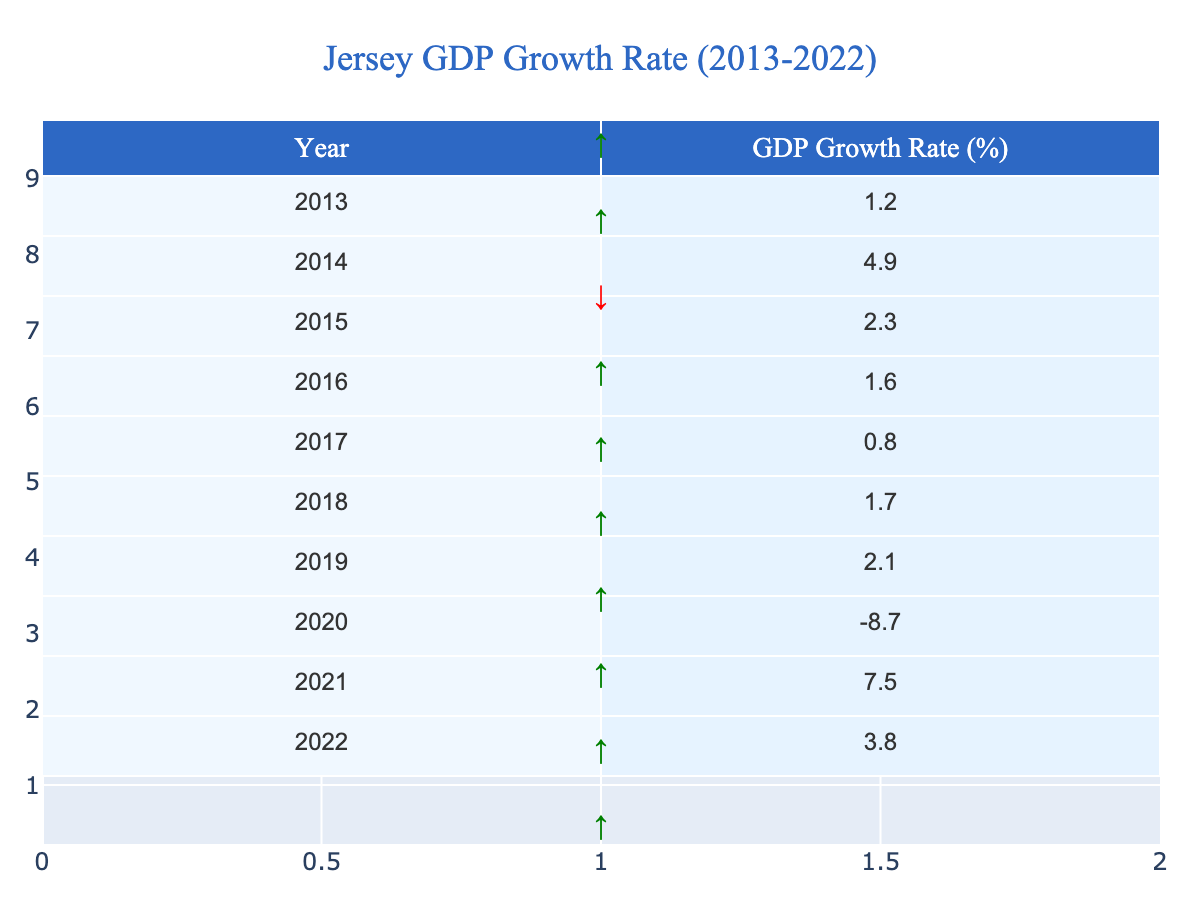What was the GDP growth rate in 2020? The table shows that the GDP growth rate for the year 2020 is recorded as -8.7%.
Answer: -8.7% Which year saw the highest GDP growth rate? According to the table, the highest GDP growth rate of 4.9% occurred in 2014.
Answer: 2014 What is the average GDP growth rate from 2013 to 2022? To find the average, we sum the GDP growth rates from each year: (1.2 + 4.9 + 2.3 + 1.6 + 0.8 + 1.7 + 2.1 - 8.7 + 7.5 + 3.8) = 18.4. Then, we divide by the number of years, which is 10. Thus, the average growth rate is 18.4 / 10 = 1.84%.
Answer: 1.84% Did Jersey experience a negative GDP growth rate at any point in the decade? The table indicates that in 2020, the GDP growth rate was -8.7%, which is negative, confirming that there was indeed a year with negative growth.
Answer: Yes What was the GDP growth rate in 2021 and how does it compare to 2020? The GDP growth rate in 2021 is 7.5%. When comparing this to 2020's rate of -8.7%, we see that there was a significant recovery, as 7.5% is much greater than -8.7%.
Answer: 7.5%, it improved significantly Which years experienced GDP growth rates above 2%? The years with GDP growth rates above 2% are 2014 (4.9%), 2015 (2.3%), 2019 (2.1%), and 2021 (7.5%).
Answer: 2014, 2015, 2019, 2021 What was the overall trend in GDP growth rates from 2013 to 2022? By assessing the values year over year, it appears that growth was generally positive but faced a sharp decline in 2020, followed by a recovery in 2021. Overall, the trend shows fluctuations with a notable dip in 2020 and recovery after.
Answer: Fluctuating with a dip in 2020 and recovery in 2021 What is the median GDP growth rate for this period? To find the median, we first list the growth rates in order: -8.7, 0.8, 1.2, 1.6, 1.7, 2.1, 2.3, 3.8, 4.9, 7.5. Since there are 10 numbers, the median will be the average of the 5th and 6th values (1.7 and 2.1), which gives (1.7 + 2.1) / 2 = 1.9%.
Answer: 1.9% In how many years was the GDP growth rate below 2%? By examining the table, we see that the years with GDP growth rates below 2% are 2013 (1.2%), 2016 (1.6%), 2017 (0.8%), and 2018 (1.7%), totaling four years below 2%.
Answer: 4 years What was the difference in GDP growth rate between 2014 and 2016? The GDP growth rate in 2014 is 4.9%, and in 2016 it's 1.6%. To find the difference, we subtract 2016's rate from 2014's: 4.9 - 1.6 = 3.3%.
Answer: 3.3% 